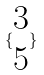<formula> <loc_0><loc_0><loc_500><loc_500>\{ \begin{matrix} 3 \\ 5 \end{matrix} \}</formula> 